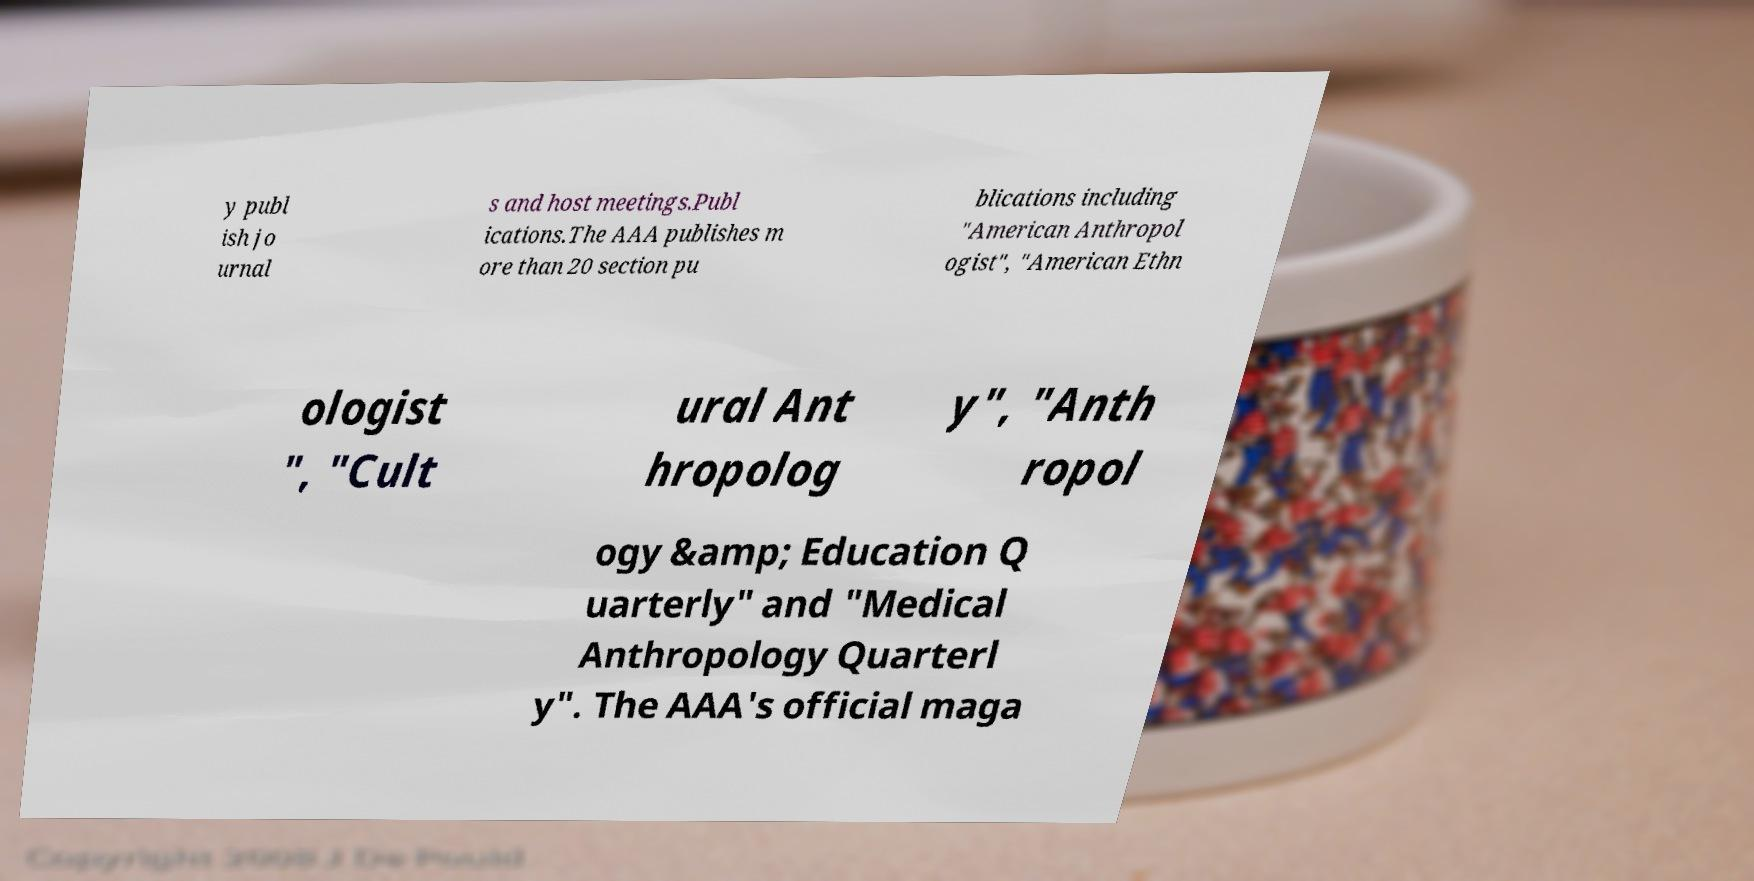Could you assist in decoding the text presented in this image and type it out clearly? y publ ish jo urnal s and host meetings.Publ ications.The AAA publishes m ore than 20 section pu blications including "American Anthropol ogist", "American Ethn ologist ", "Cult ural Ant hropolog y", "Anth ropol ogy &amp; Education Q uarterly" and "Medical Anthropology Quarterl y". The AAA's official maga 